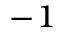<formula> <loc_0><loc_0><loc_500><loc_500>^ { - 1 }</formula> 